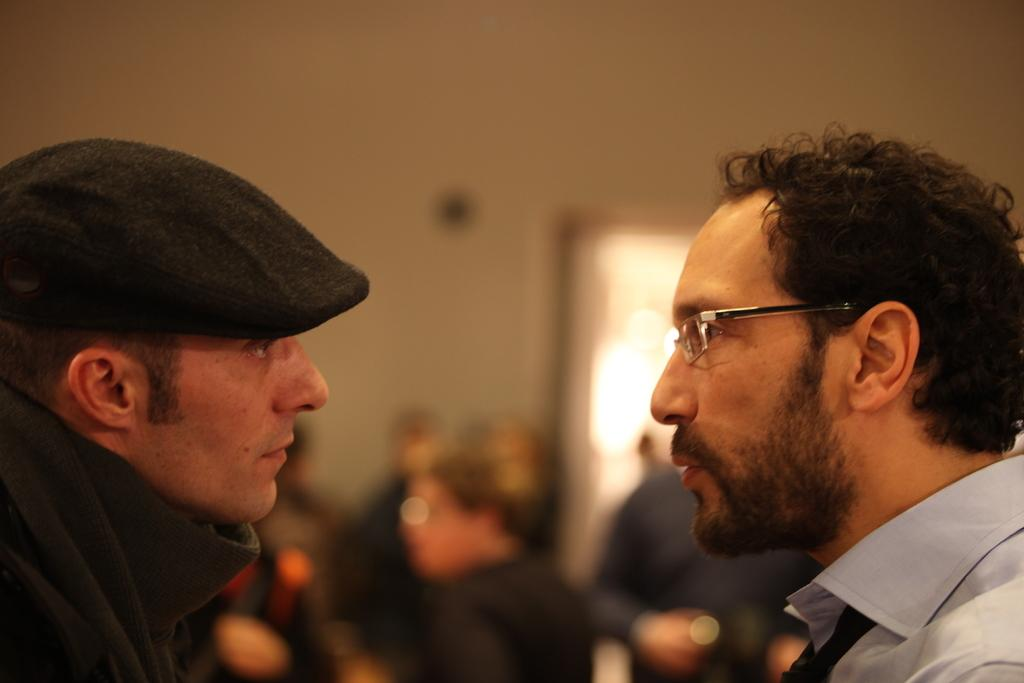How many people are in the image? There are two men in the image. Can you describe the clothing of the first man? The first man is wearing a hat and a jerkin. How about the second man? The second man is wearing spectacles, a shirt, and a tie. What can be said about the background of the image? The background of the image appears blurry. What type of wrench is the man using to fix the donkey in the image? There is no wrench or donkey present in the image; it features two men with specific clothing. 